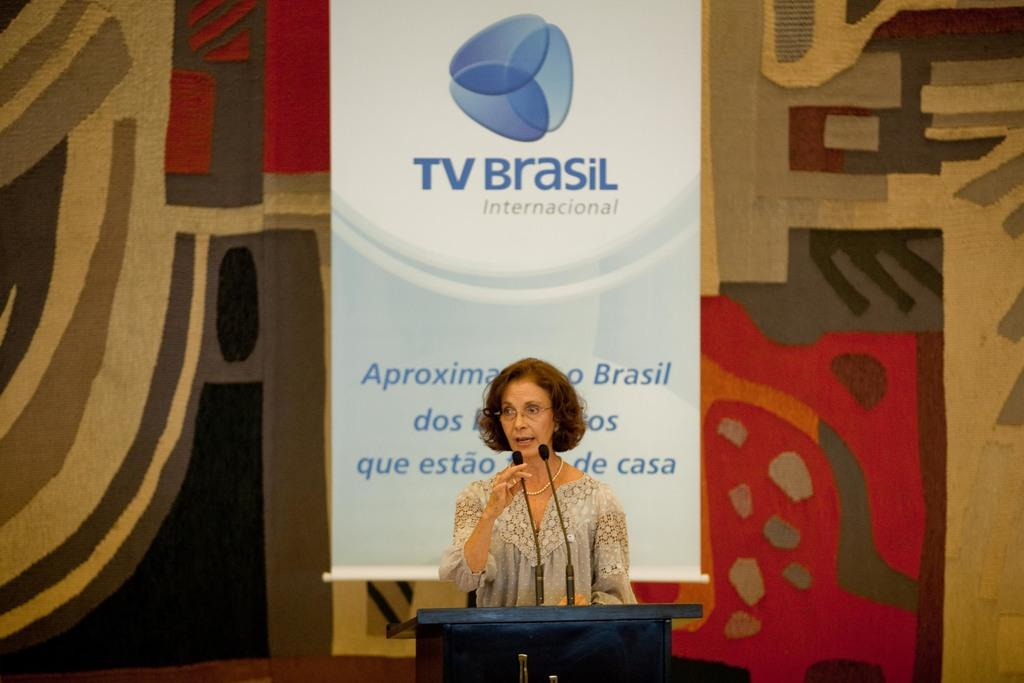<image>
Render a clear and concise summary of the photo. female speaker at podium with a tv brasil banner behind her 